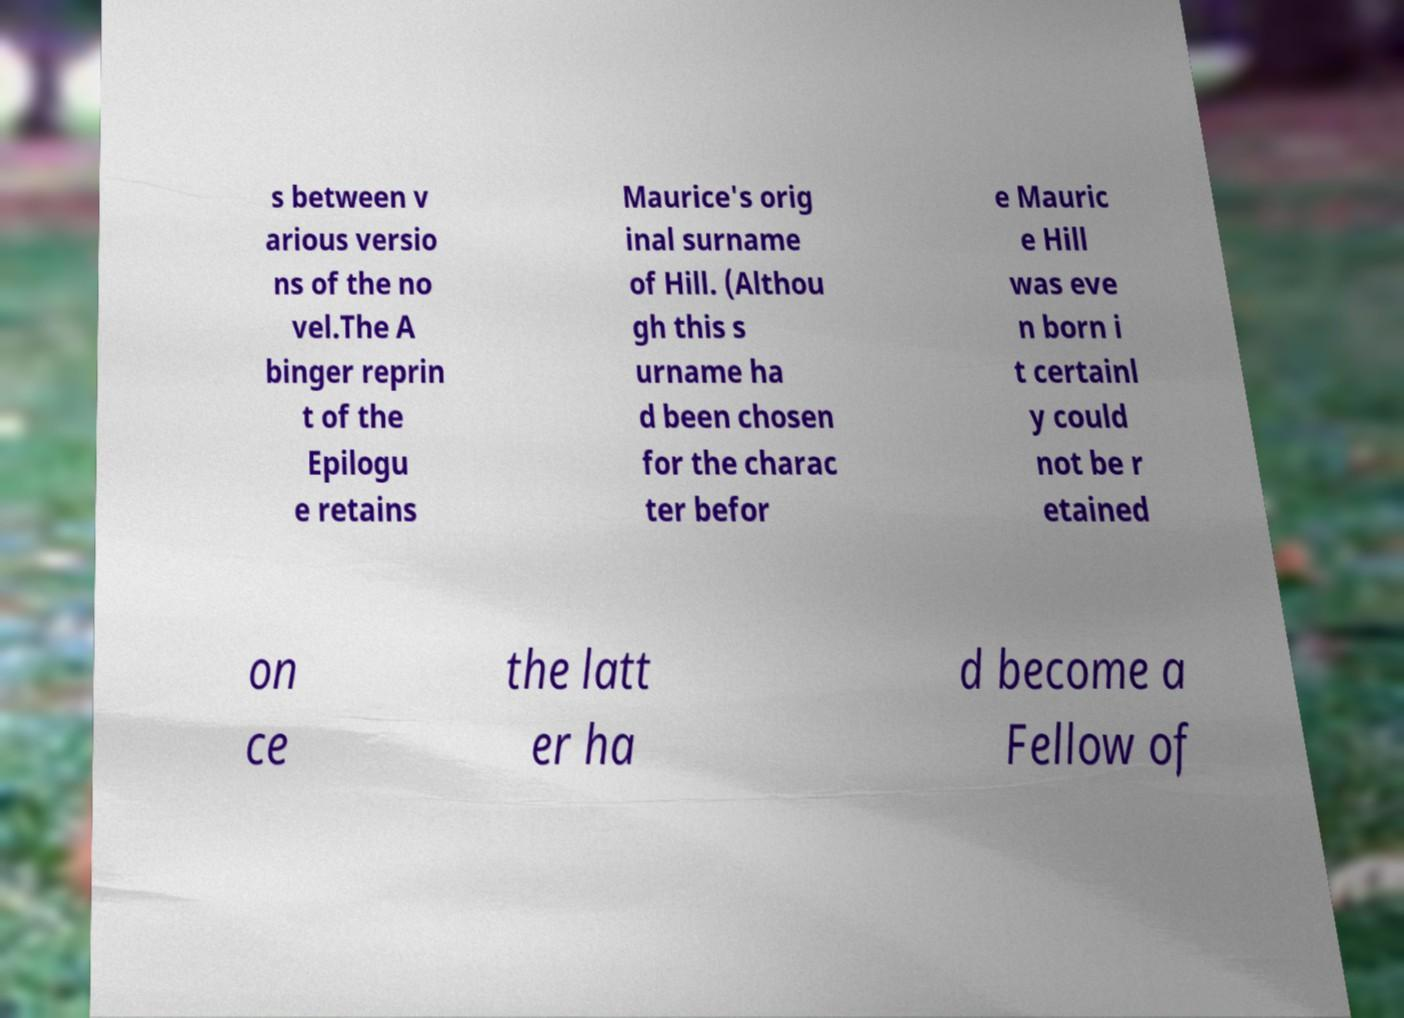Can you accurately transcribe the text from the provided image for me? s between v arious versio ns of the no vel.The A binger reprin t of the Epilogu e retains Maurice's orig inal surname of Hill. (Althou gh this s urname ha d been chosen for the charac ter befor e Mauric e Hill was eve n born i t certainl y could not be r etained on ce the latt er ha d become a Fellow of 